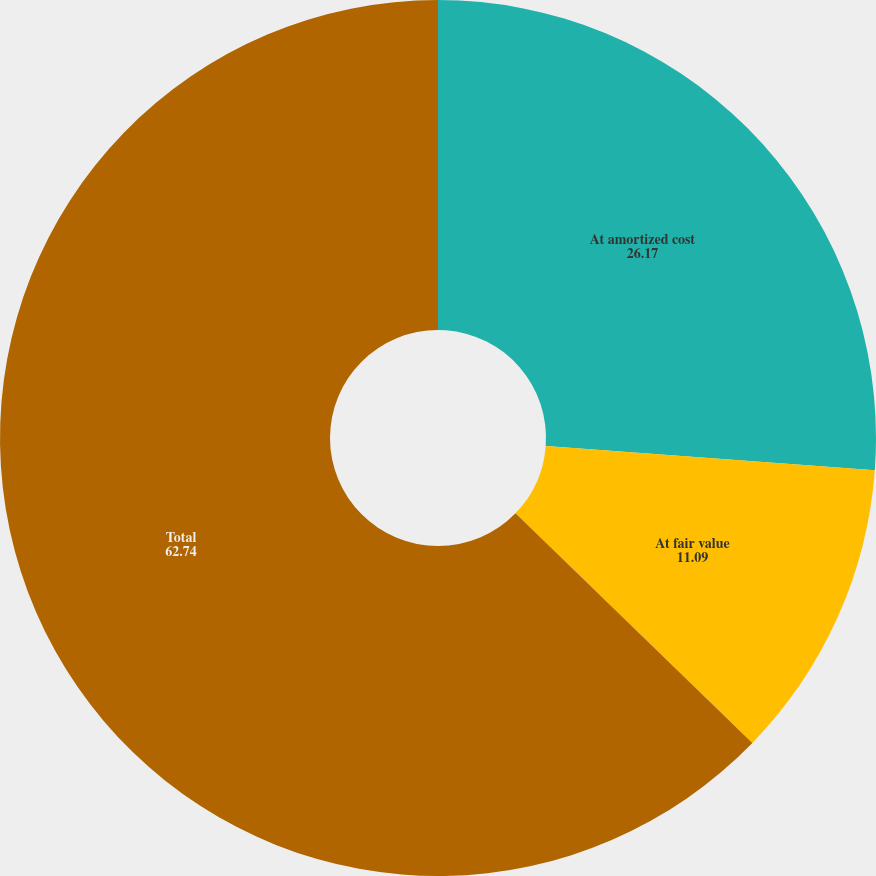Convert chart. <chart><loc_0><loc_0><loc_500><loc_500><pie_chart><fcel>At amortized cost<fcel>At fair value<fcel>Total<nl><fcel>26.17%<fcel>11.09%<fcel>62.74%<nl></chart> 